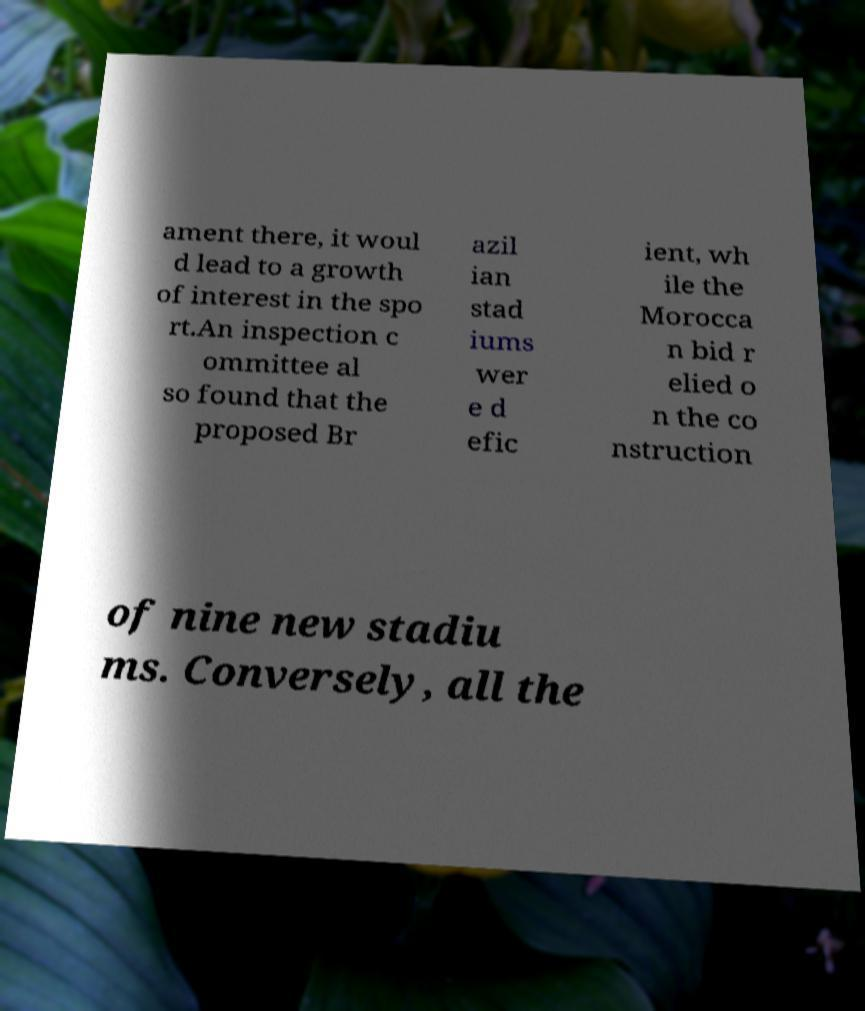Can you accurately transcribe the text from the provided image for me? ament there, it woul d lead to a growth of interest in the spo rt.An inspection c ommittee al so found that the proposed Br azil ian stad iums wer e d efic ient, wh ile the Morocca n bid r elied o n the co nstruction of nine new stadiu ms. Conversely, all the 